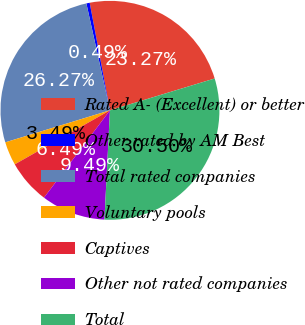<chart> <loc_0><loc_0><loc_500><loc_500><pie_chart><fcel>Rated A- (Excellent) or better<fcel>Other rated by AM Best<fcel>Total rated companies<fcel>Voluntary pools<fcel>Captives<fcel>Other not rated companies<fcel>Total<nl><fcel>23.27%<fcel>0.49%<fcel>26.27%<fcel>3.49%<fcel>6.49%<fcel>9.49%<fcel>30.5%<nl></chart> 